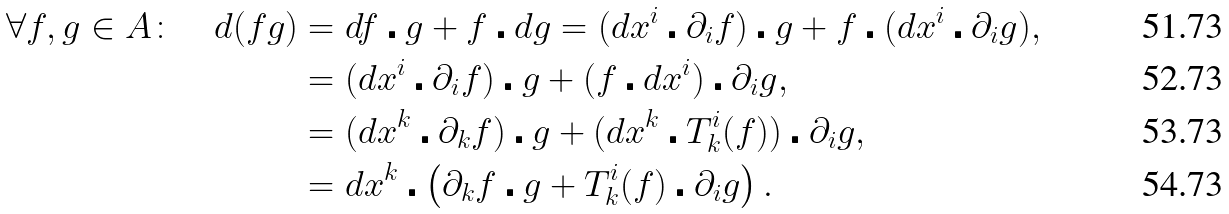<formula> <loc_0><loc_0><loc_500><loc_500>\forall f , g \in A \colon \quad d ( f g ) & = d f \centerdot g + f \centerdot d g = ( d x ^ { i } \centerdot \partial _ { i } f ) \centerdot g + f \centerdot ( d x ^ { i } \centerdot \partial _ { i } g ) , \\ & = ( d x ^ { i } \centerdot \partial _ { i } f ) \centerdot g + ( f \centerdot d x ^ { i } ) \centerdot \partial _ { i } g , \\ & = ( d x ^ { k } \centerdot \partial _ { k } f ) \centerdot g + ( d x ^ { k } \centerdot T ^ { i } _ { k } ( f ) ) \centerdot \partial _ { i } g , \\ & = d x ^ { k } \centerdot \left ( \partial _ { k } f \centerdot g + T ^ { i } _ { k } ( f ) \centerdot \partial _ { i } g \right ) .</formula> 